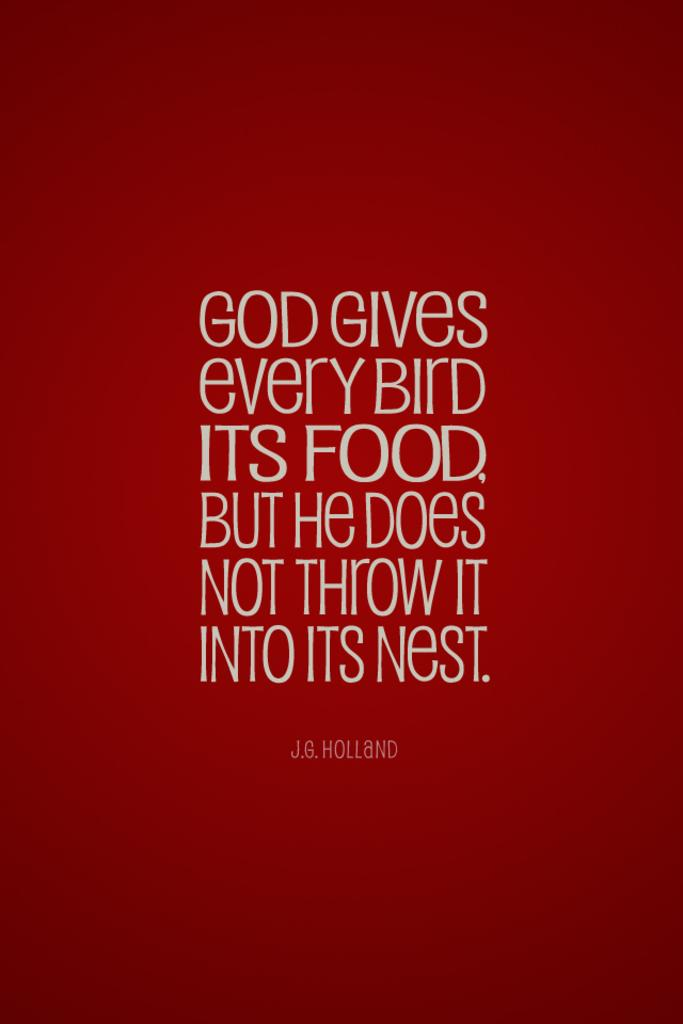<image>
Present a compact description of the photo's key features. a quote that talks about a bird and food 